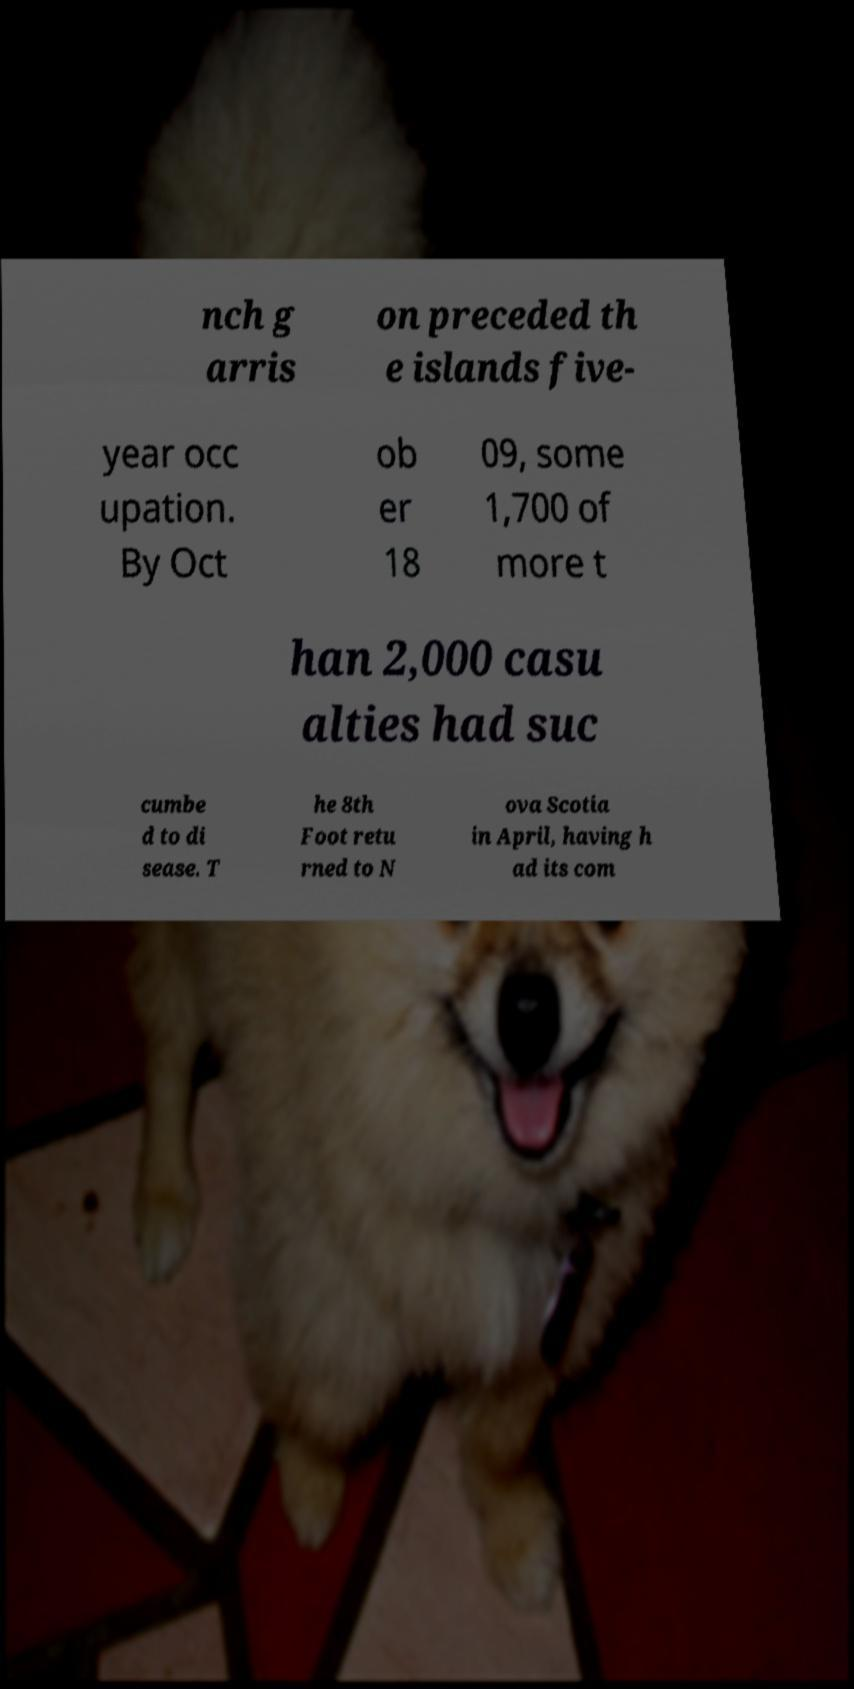Please read and relay the text visible in this image. What does it say? nch g arris on preceded th e islands five- year occ upation. By Oct ob er 18 09, some 1,700 of more t han 2,000 casu alties had suc cumbe d to di sease. T he 8th Foot retu rned to N ova Scotia in April, having h ad its com 